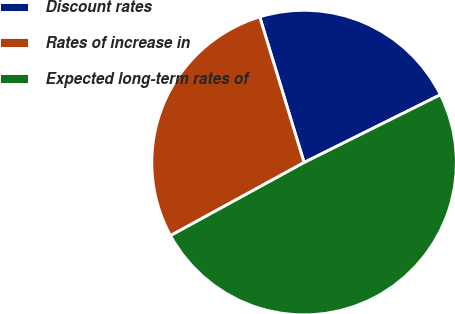Convert chart. <chart><loc_0><loc_0><loc_500><loc_500><pie_chart><fcel>Discount rates<fcel>Rates of increase in<fcel>Expected long-term rates of<nl><fcel>22.36%<fcel>28.26%<fcel>49.38%<nl></chart> 